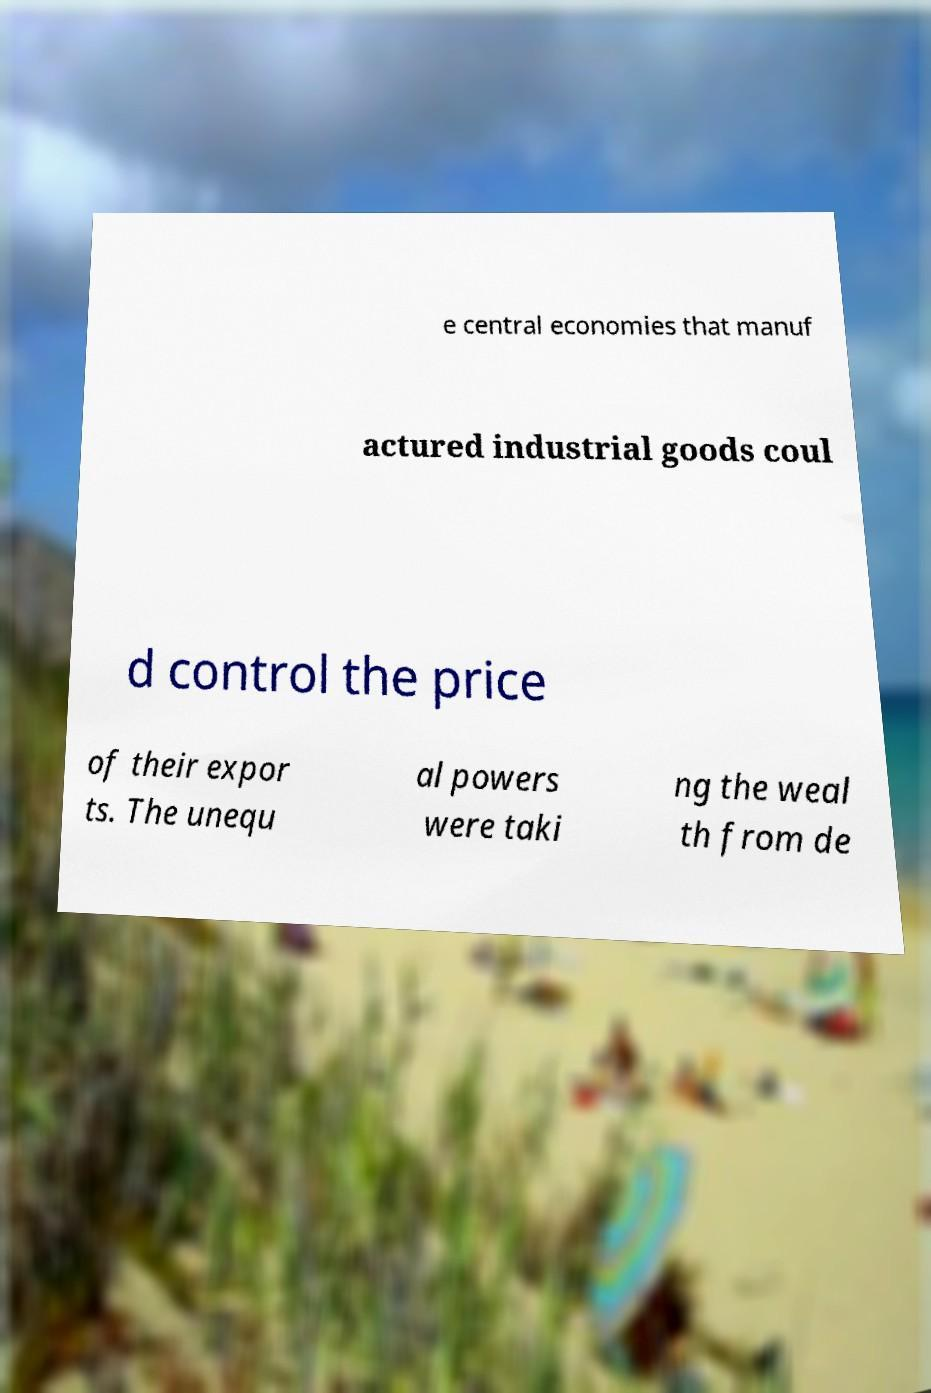I need the written content from this picture converted into text. Can you do that? e central economies that manuf actured industrial goods coul d control the price of their expor ts. The unequ al powers were taki ng the weal th from de 